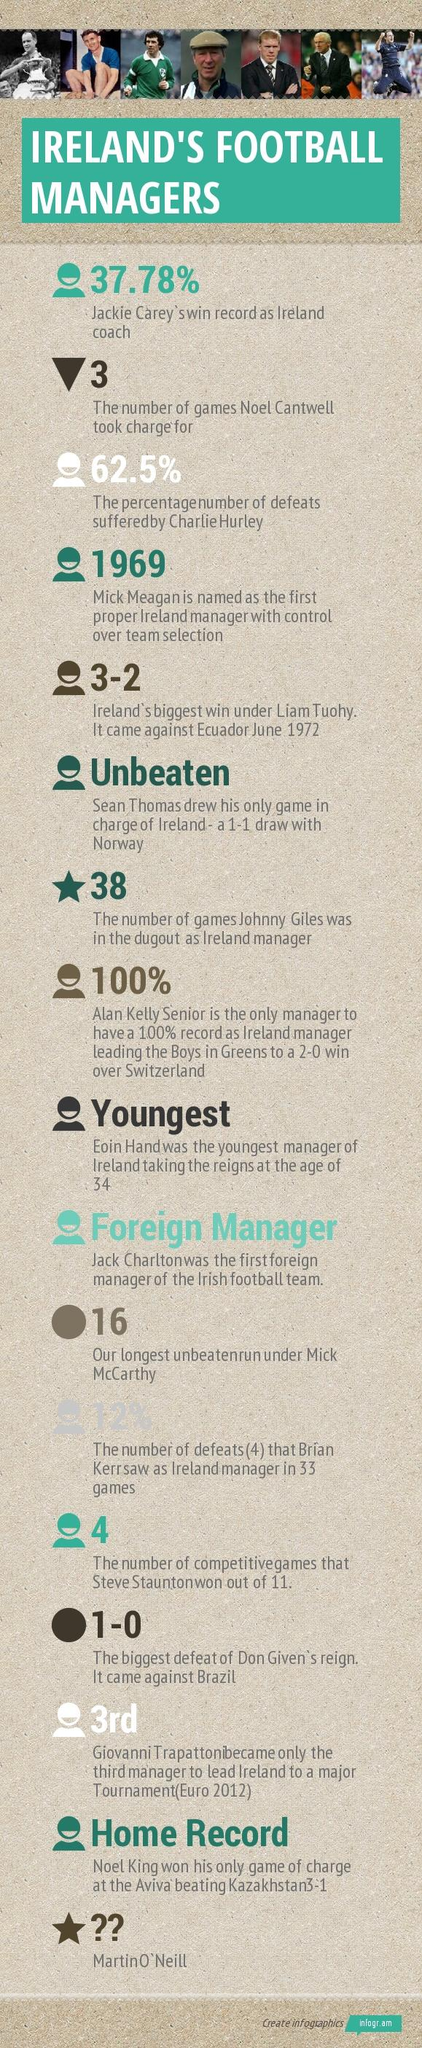Highlight a few significant elements in this photo. Charlie Hurley suffered 62.5% of his defeats. 